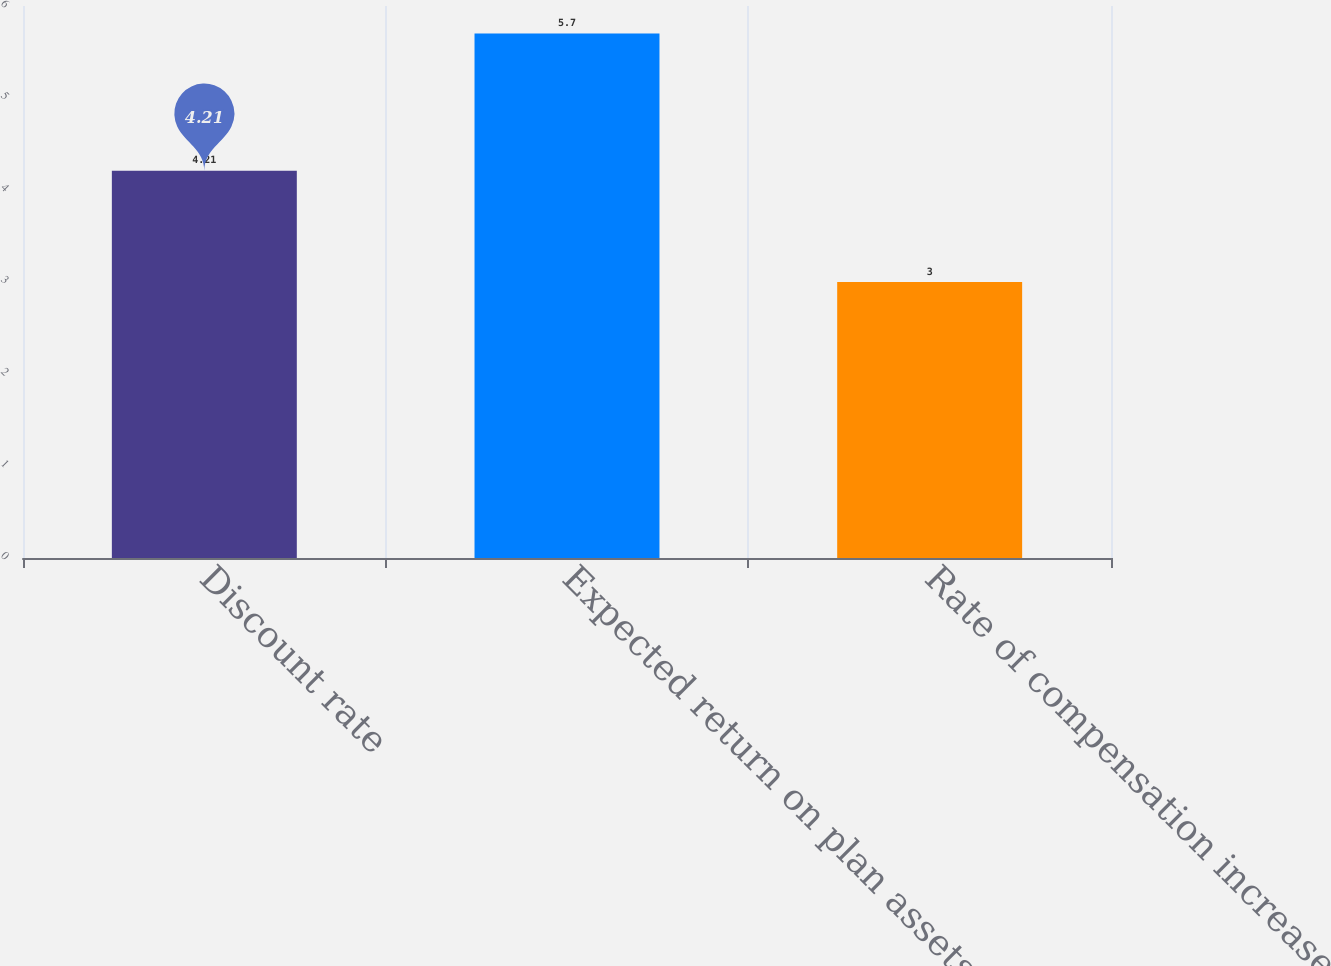<chart> <loc_0><loc_0><loc_500><loc_500><bar_chart><fcel>Discount rate<fcel>Expected return on plan assets<fcel>Rate of compensation increase<nl><fcel>4.21<fcel>5.7<fcel>3<nl></chart> 